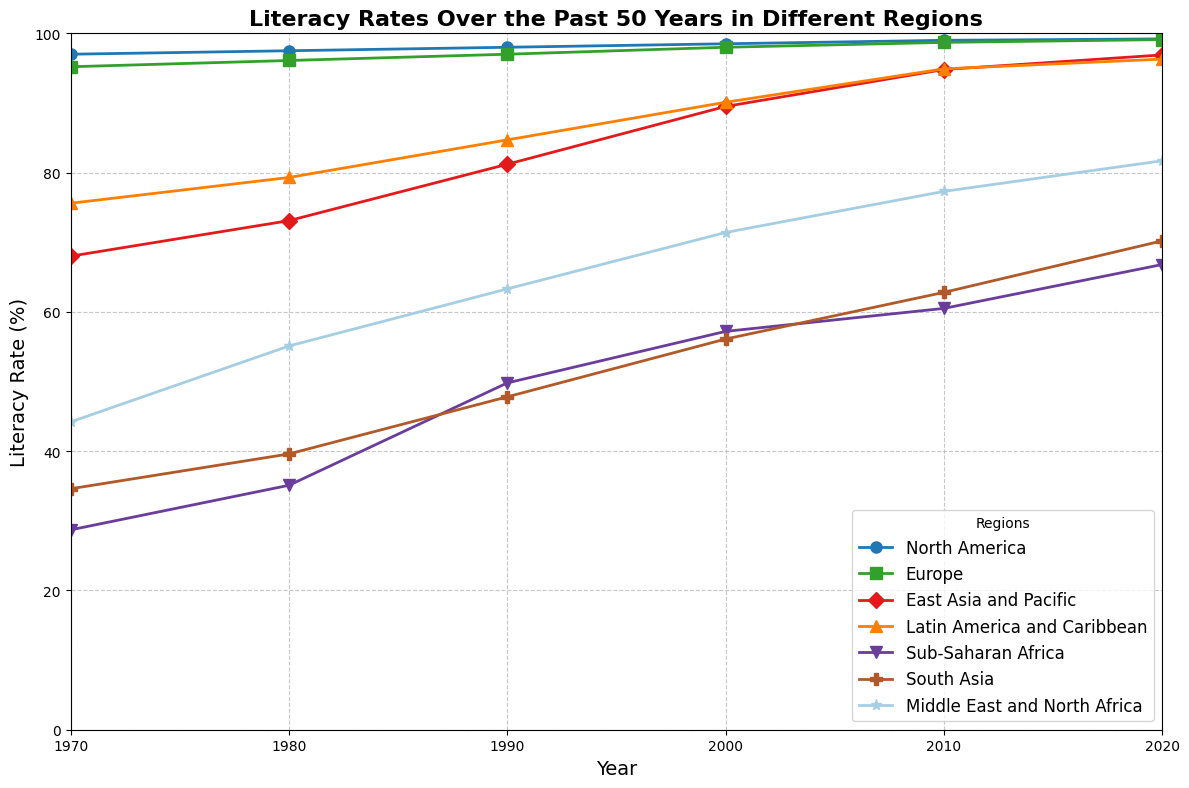What's the overall trend in literacy rates for Sub-Saharan Africa from 1970 to 2020? The plot shows a steady increase in literacy rates for Sub-Saharan Africa from 28.7% in 1970 to 66.8% in 2020.
Answer: Steady increase Which region shows the greatest increase in literacy rates between 1970 and 2020? By comparing the endpoints of each line, South Asia shows the most significant increase, from 34.6% in 1970 to 70.2% in 2020.
Answer: South Asia By how much has the literacy rate in East Asia and Pacific increased from 1970 to 2020? The literacy rate in East Asia and Pacific in 1970 was 68.0% and increased to 96.9% in 2020. To find the increase: 96.9% - 68.0% = 28.9%.
Answer: 28.9% Which region had the highest literacy rate in 1990, and what was the value? Looking at the values for 1990, North America had the highest literacy rate at 98.0%.
Answer: North America, 98.0% Between 2000 and 2010, which region had the smallest change in literacy rates? The smallest change can be observed by finding the differences for each region between 2000 and 2010 and seeing that Europe changed from 98.0% to 98.7%, a difference of 0.7%.
Answer: Europe What is the average literacy rate for Latin America and Caribbean from 1970 to 2020? Summing the values for Latin America and Caribbean (75.6, 79.3, 84.7, 90.1, 94.9, 96.3) and dividing by the number of data points (6): (75.6 + 79.3 + 84.7 + 90.1 + 94.9 + 96.3) / 6 = 86.48%.
Answer: 86.48% If you compare the literacy rates of South Asia and the Middle East and North Africa in 2020, which one is higher and by how much? South Asia in 2020 has a rate of 70.2%, and the Middle East and North Africa has 81.7%. The difference is 81.7% - 70.2% = 11.5%.
Answer: Middle East and North Africa, 11.5% How much did the literacy rate increase in North America from 1970 to 1980? In 1970, North America's literacy rate was 97.0% and in 1980 it was 97.5%. The increase is 97.5% - 97.0% = 0.5%.
Answer: 0.5% What color represents the region with the lowest literacy rate in 1970, and what is this region? Sub-Saharan Africa had the lowest literacy rate in 1970 at 28.7%, and it is typically represented in blue in such plots.
Answer: Blue, Sub-Saharan Africa 